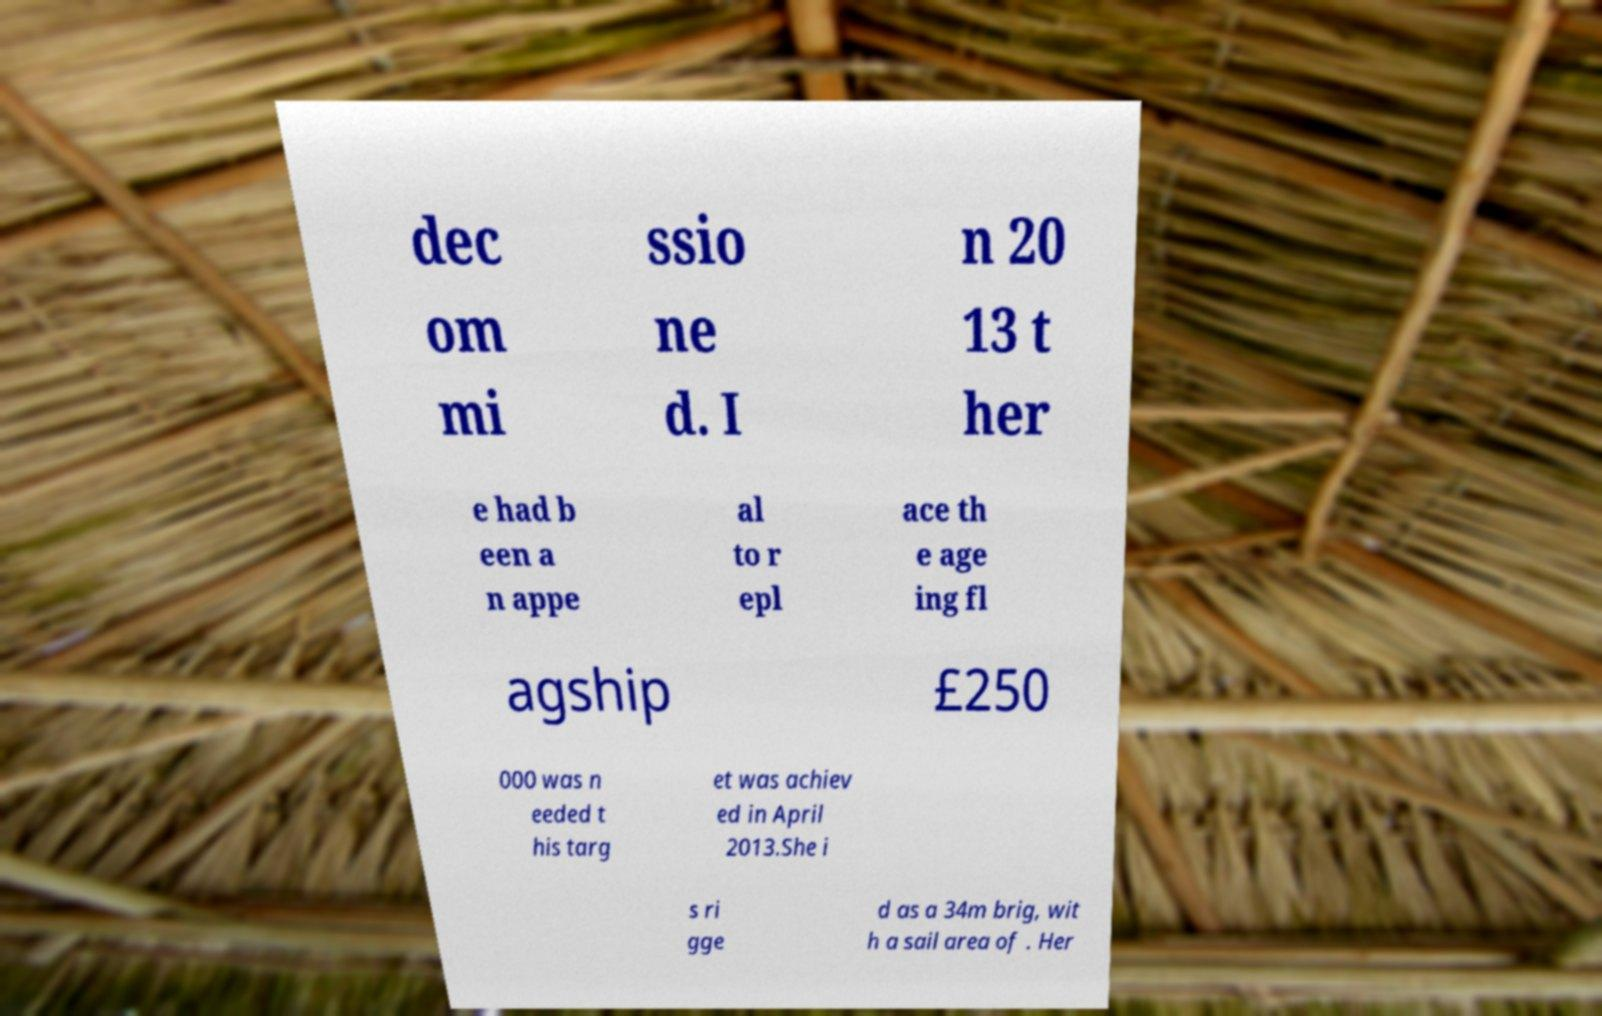For documentation purposes, I need the text within this image transcribed. Could you provide that? dec om mi ssio ne d. I n 20 13 t her e had b een a n appe al to r epl ace th e age ing fl agship £250 000 was n eeded t his targ et was achiev ed in April 2013.She i s ri gge d as a 34m brig, wit h a sail area of . Her 